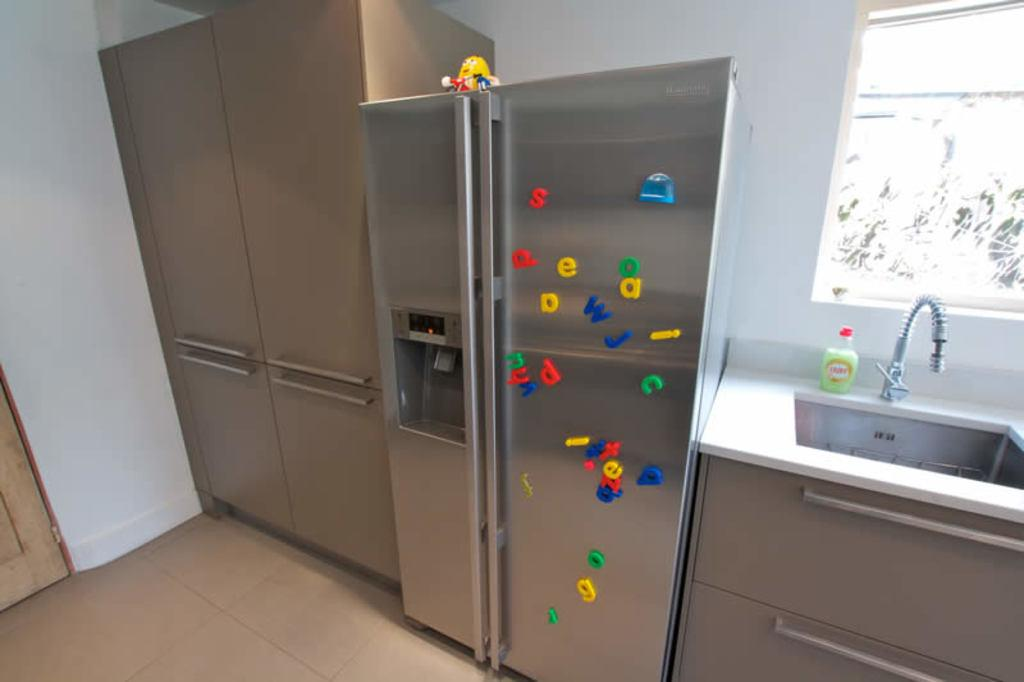<image>
Give a short and clear explanation of the subsequent image. The refrigerator has magnets with letters of the alphabet in blue, yellow, and green, including the letters 'w' and 'j' in blue. 